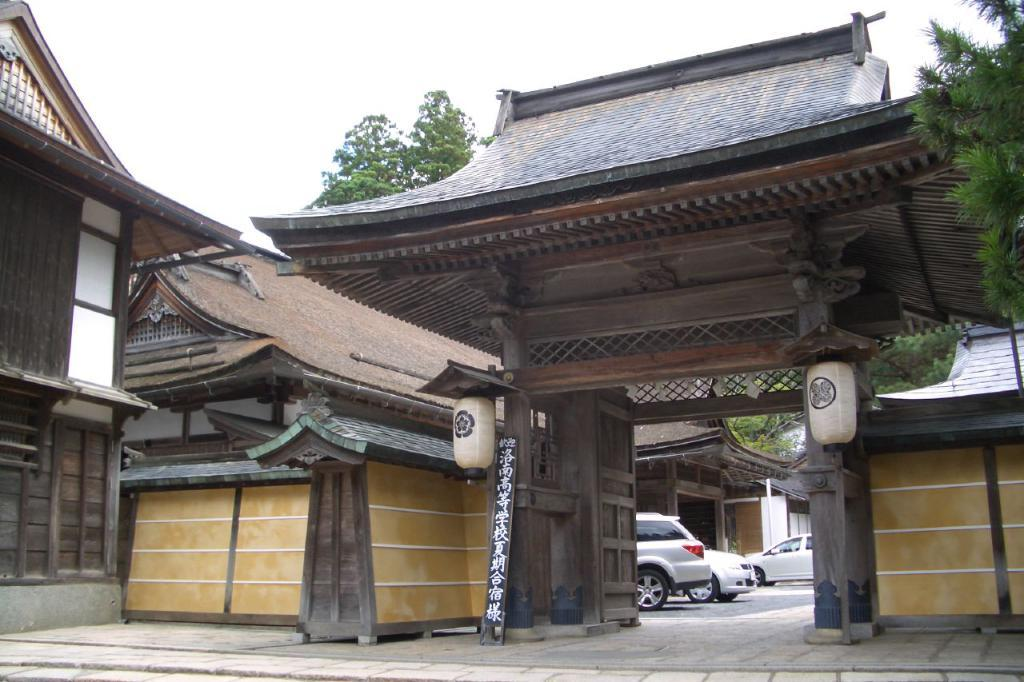What type of structure is visible in the image? There is a building in the image. What can be seen beside the building? There are trees beside the building. What is parked in front of the building? There are vehicles parked in front of the building. What is visible in the background of the image? The sky is visible in the background of the image. How many legs does the beetle have in the image? There is no beetle present in the image. What type of engine is visible in the image? There is no engine visible in the image; only vehicles are parked in front of the building. 